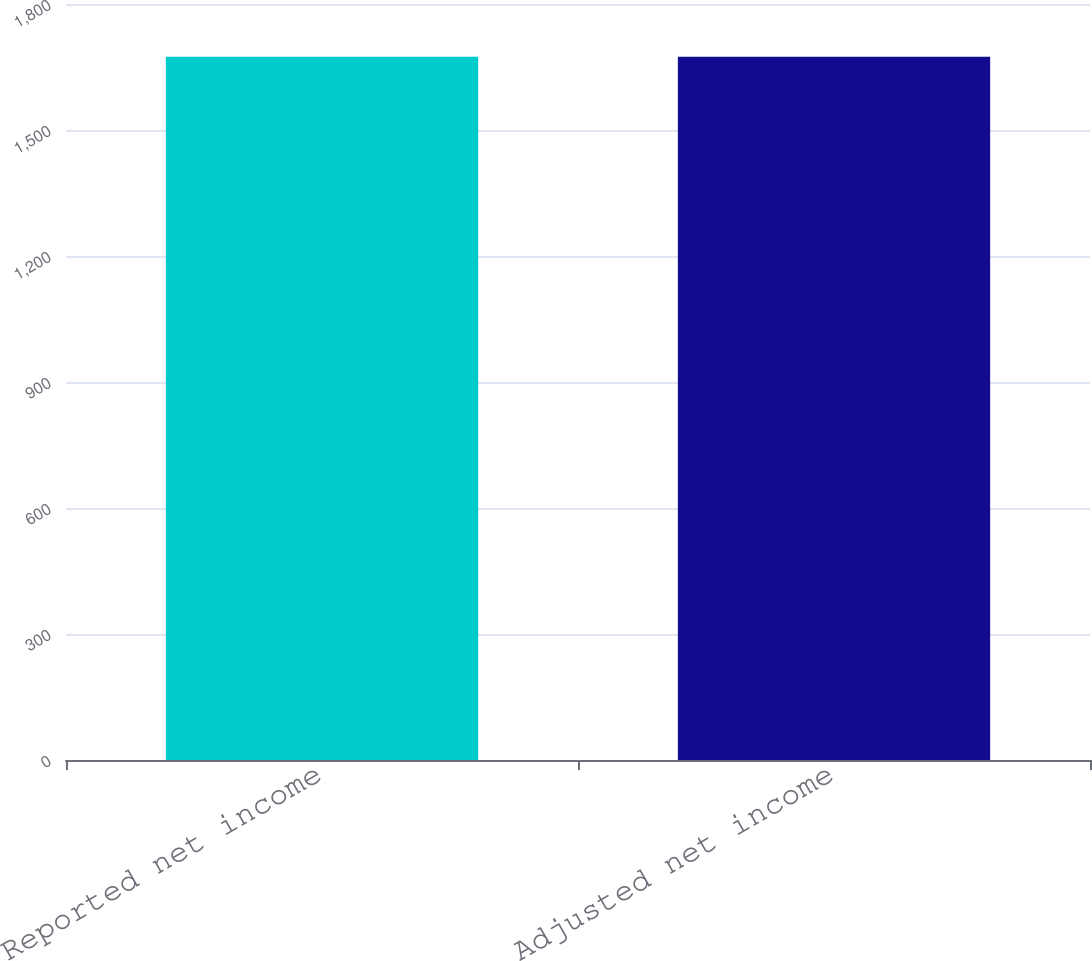<chart> <loc_0><loc_0><loc_500><loc_500><bar_chart><fcel>Reported net income<fcel>Adjusted net income<nl><fcel>1674.6<fcel>1674.7<nl></chart> 